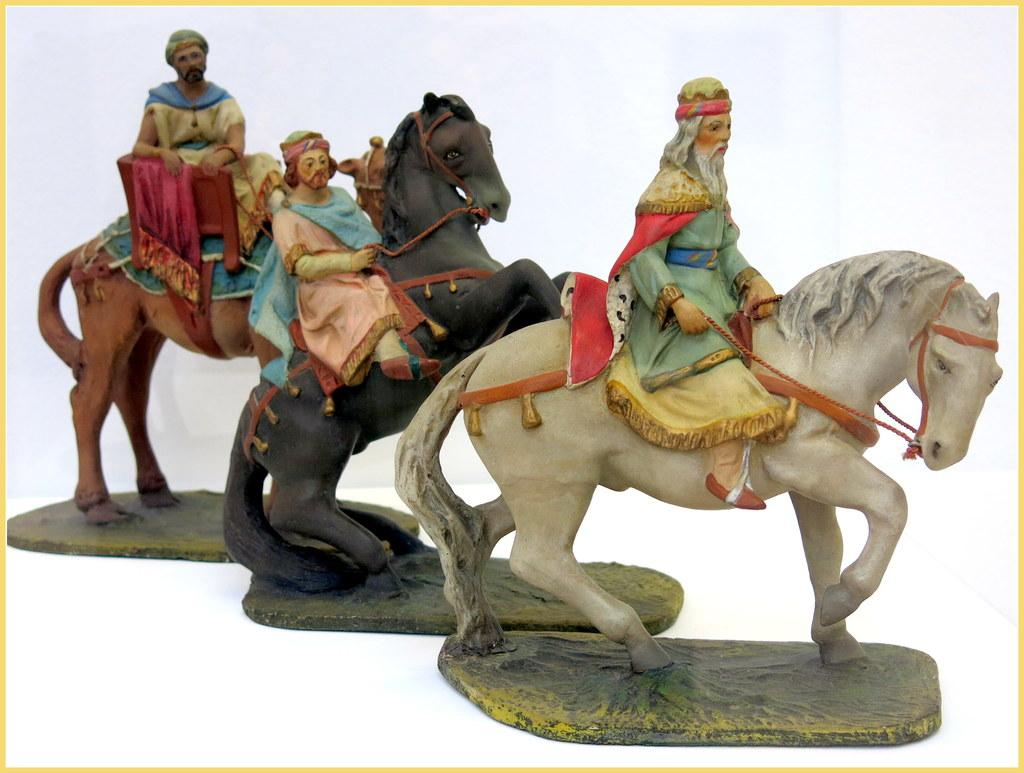What type of toys are present in the image? There are toys of horses and toys of persons in the image. Where are the toys located in the image? The toys are located in the center of the image. What is the distance between the toys and the afterthought in the image? There is no mention of an afterthought in the image, so it is not possible to determine the distance between the toys and an afterthought. 